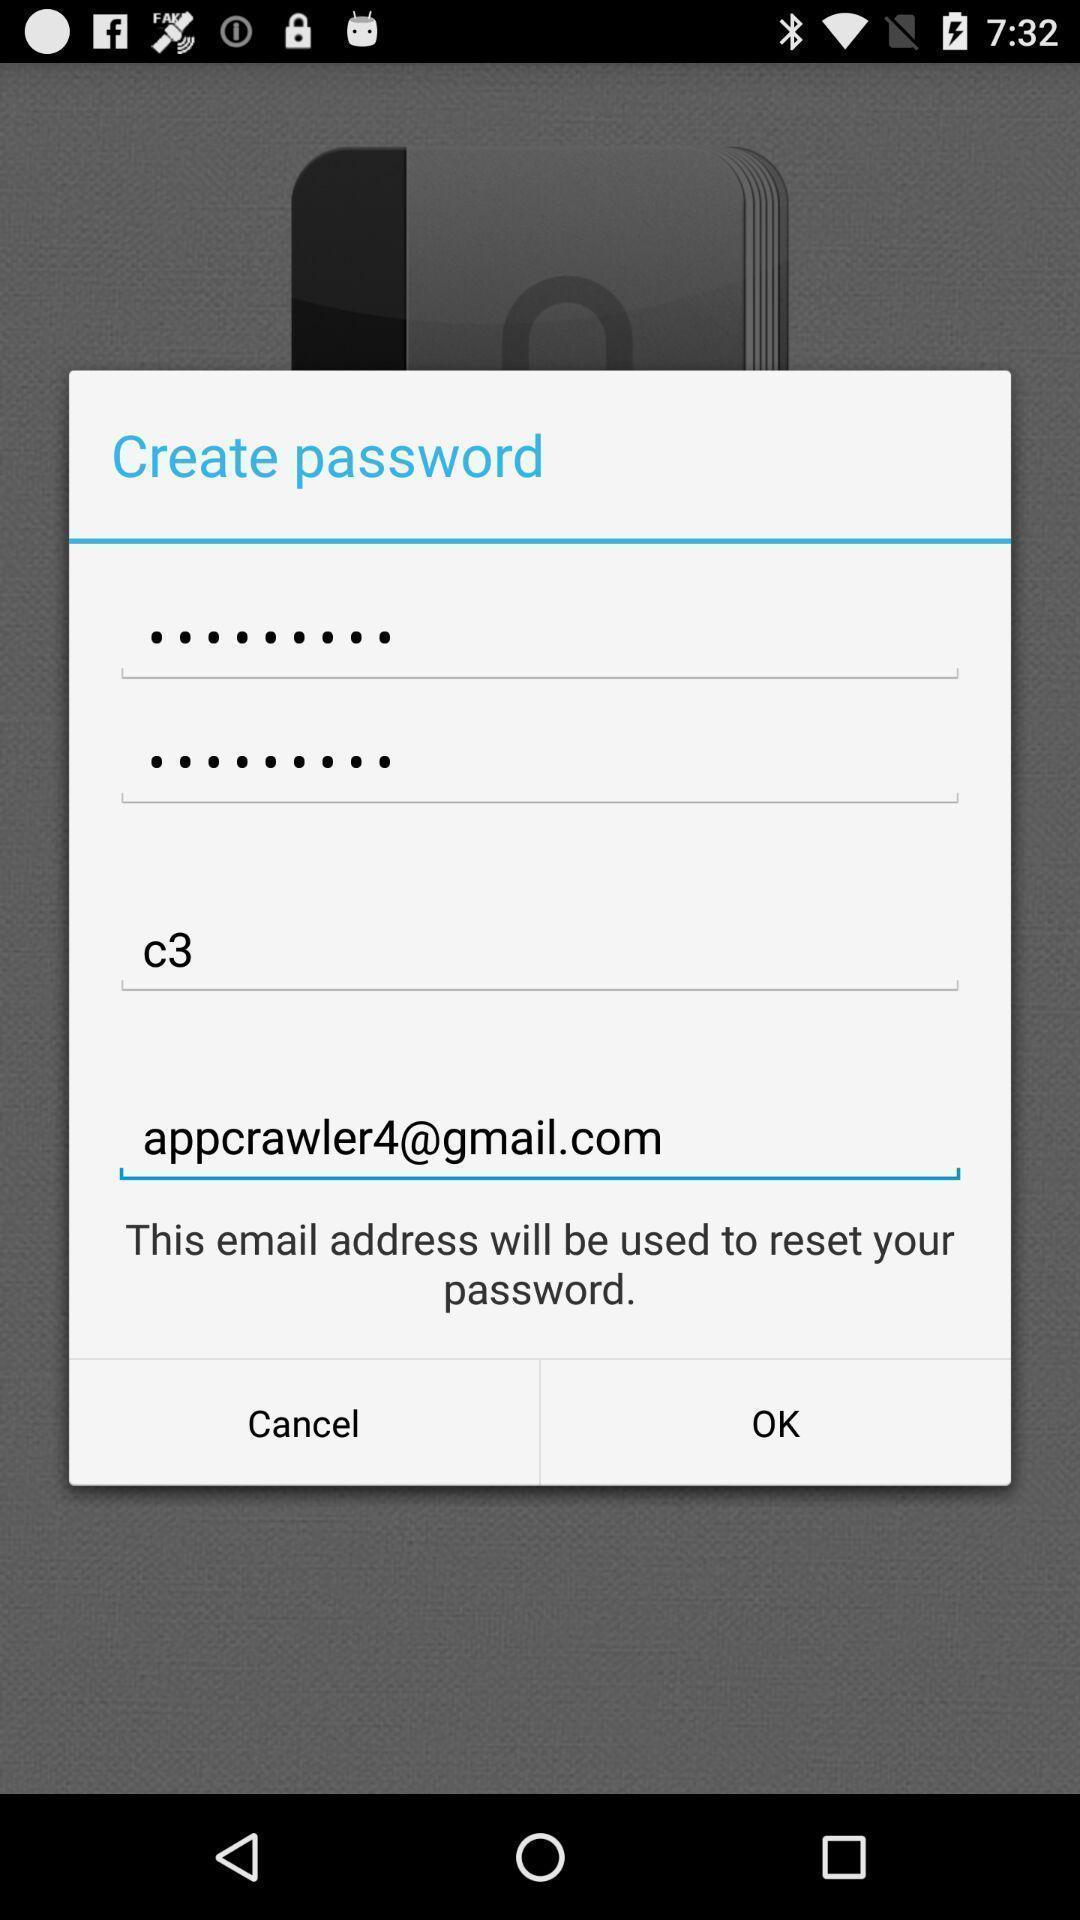What is the overall content of this screenshot? Pop-up window showing input boxes for creating passwords. 